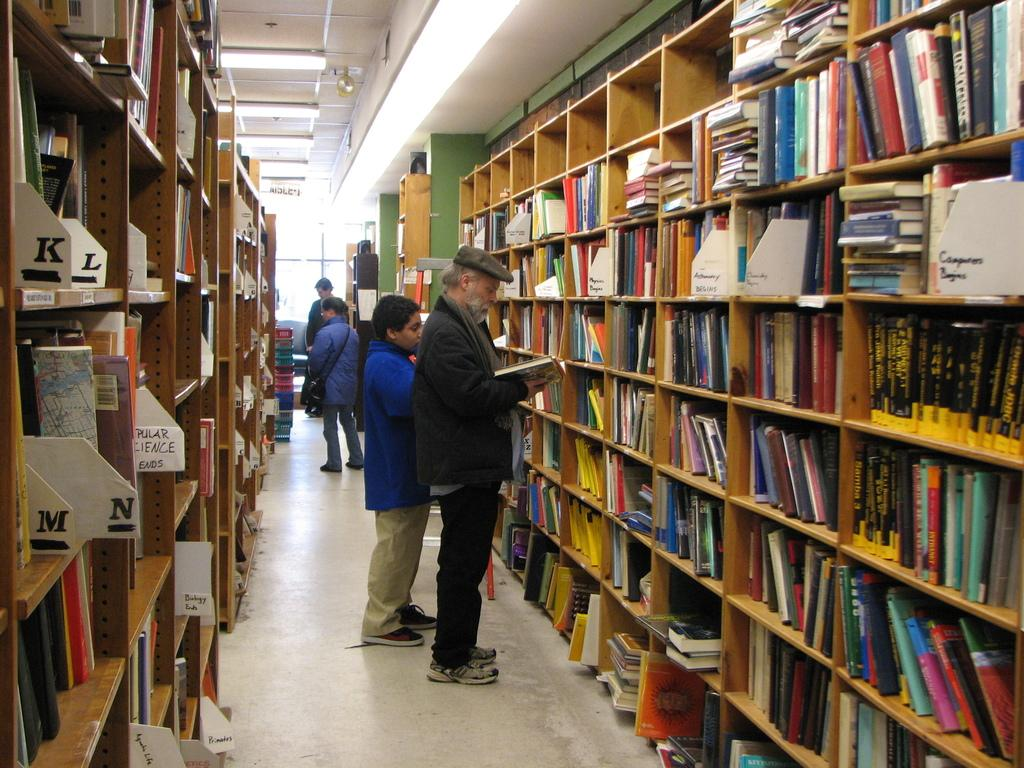<image>
Create a compact narrative representing the image presented. A few people looking at books on shelves and a section is labeled for popular science. 